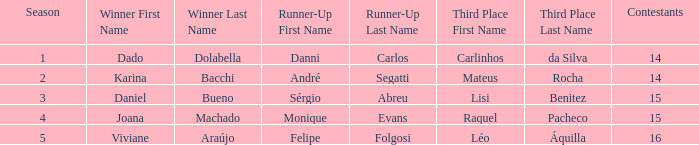How many contestants were there when the runner-up was Monique Evans? 15.0. Could you parse the entire table? {'header': ['Season', 'Winner First Name', 'Winner Last Name', 'Runner-Up First Name', 'Runner-Up Last Name', 'Third Place First Name', 'Third Place Last Name', 'Contestants'], 'rows': [['1', 'Dado', 'Dolabella', 'Danni', 'Carlos', 'Carlinhos', 'da Silva', '14'], ['2', 'Karina', 'Bacchi', 'André', 'Segatti', 'Mateus', 'Rocha', '14'], ['3', 'Daniel', 'Bueno', 'Sérgio', 'Abreu', 'Lisi', 'Benitez', '15'], ['4', 'Joana', 'Machado', 'Monique', 'Evans', 'Raquel', 'Pacheco', '15'], ['5', 'Viviane', 'Araújo', 'Felipe', 'Folgosi', 'Léo', 'Áquilla', '16']]} 